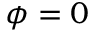Convert formula to latex. <formula><loc_0><loc_0><loc_500><loc_500>\phi = 0</formula> 